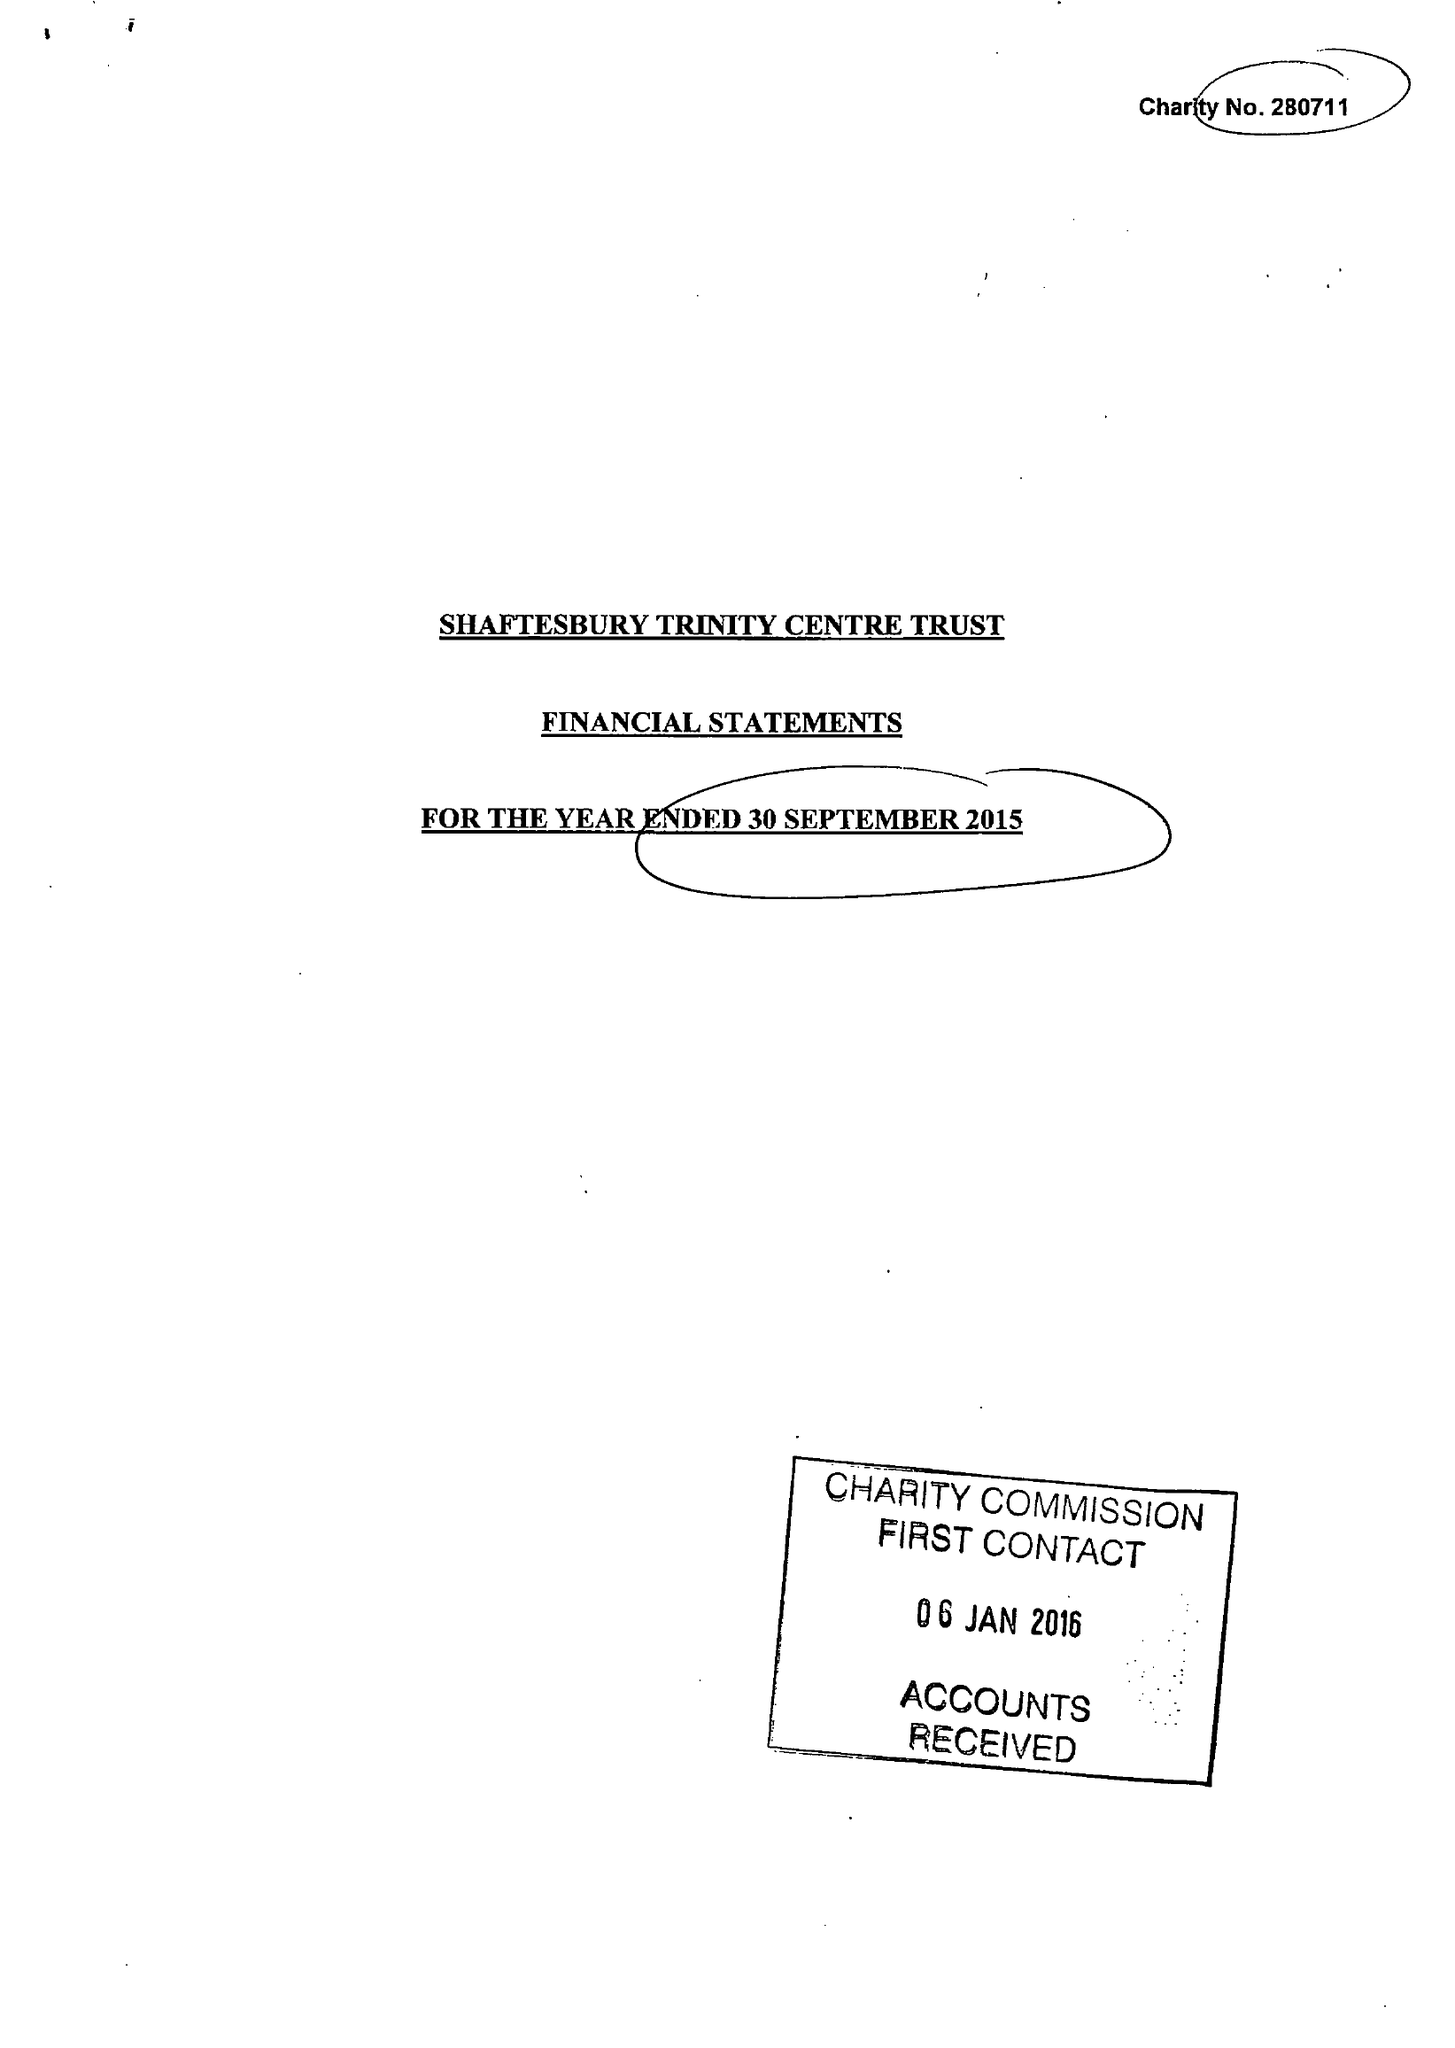What is the value for the charity_number?
Answer the question using a single word or phrase. 280711 